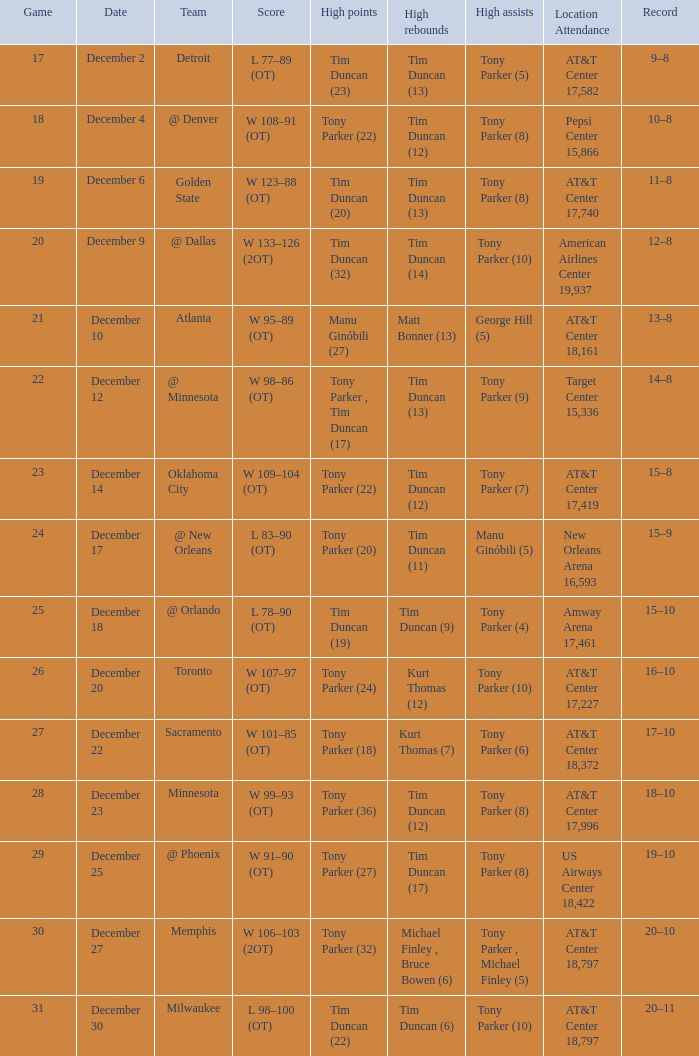What team has tony parker (10) as the high assists, kurt thomas (12) as the high rebounds? Toronto. 